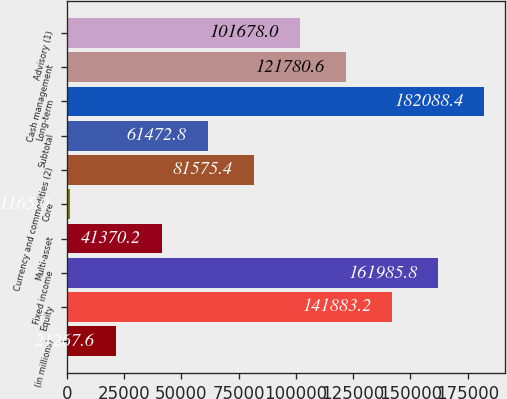Convert chart to OTSL. <chart><loc_0><loc_0><loc_500><loc_500><bar_chart><fcel>(in millions)<fcel>Equity<fcel>Fixed income<fcel>Multi-asset<fcel>Core<fcel>Currency and commodities (2)<fcel>Subtotal<fcel>Long-term<fcel>Cash management<fcel>Advisory (1)<nl><fcel>21267.6<fcel>141883<fcel>161986<fcel>41370.2<fcel>1165<fcel>81575.4<fcel>61472.8<fcel>182088<fcel>121781<fcel>101678<nl></chart> 